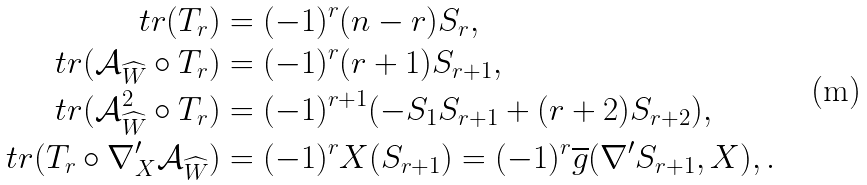<formula> <loc_0><loc_0><loc_500><loc_500>t r ( T _ { r } ) & = ( - 1 ) ^ { r } ( n - r ) S _ { r } , \\ t r ( \mathcal { A } _ { \widehat { W } } \circ T _ { r } ) & = ( - 1 ) ^ { r } ( r + 1 ) S _ { r + 1 } , \\ t r ( \mathcal { A } _ { \widehat { W } } ^ { 2 } \circ T _ { r } ) & = ( - 1 ) ^ { r + 1 } ( - S _ { 1 } S _ { r + 1 } + ( r + 2 ) S _ { r + 2 } ) , \\ t r ( T _ { r } \circ \nabla ^ { \prime } _ { X } \mathcal { A } _ { \widehat { W } } ) & = ( - 1 ) ^ { r } X ( S _ { r + 1 } ) = ( - 1 ) ^ { r } \overline { g } ( \nabla ^ { \prime } S _ { r + 1 } , X ) , .</formula> 